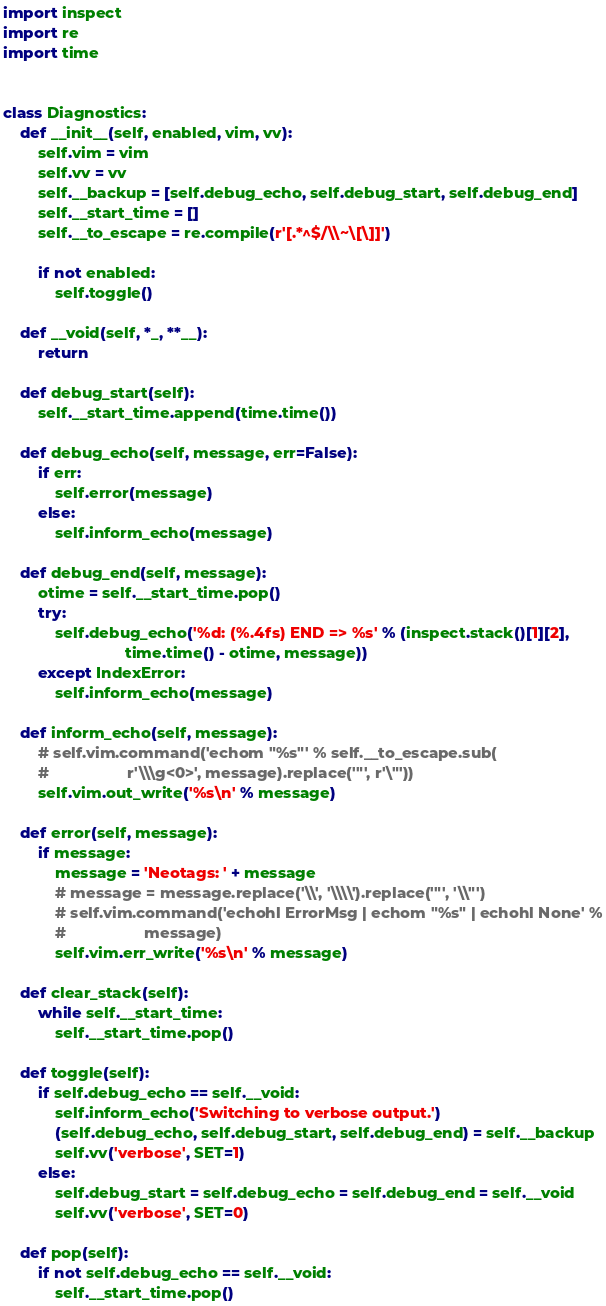Convert code to text. <code><loc_0><loc_0><loc_500><loc_500><_Python_>import inspect
import re
import time


class Diagnostics:
    def __init__(self, enabled, vim, vv):
        self.vim = vim
        self.vv = vv
        self.__backup = [self.debug_echo, self.debug_start, self.debug_end]
        self.__start_time = []
        self.__to_escape = re.compile(r'[.*^$/\\~\[\]]')

        if not enabled:
            self.toggle()

    def __void(self, *_, **__):
        return

    def debug_start(self):
        self.__start_time.append(time.time())

    def debug_echo(self, message, err=False):
        if err:
            self.error(message)
        else:
            self.inform_echo(message)

    def debug_end(self, message):
        otime = self.__start_time.pop()
        try:
            self.debug_echo('%d: (%.4fs) END => %s' % (inspect.stack()[1][2],
                            time.time() - otime, message))
        except IndexError:
            self.inform_echo(message)

    def inform_echo(self, message):
        # self.vim.command('echom "%s"' % self.__to_escape.sub(
        #                  r'\\\g<0>', message).replace('"', r'\"'))
        self.vim.out_write('%s\n' % message)

    def error(self, message):
        if message:
            message = 'Neotags: ' + message
            # message = message.replace('\\', '\\\\').replace('"', '\\"')
            # self.vim.command('echohl ErrorMsg | echom "%s" | echohl None' %
            #                  message)
            self.vim.err_write('%s\n' % message)

    def clear_stack(self):
        while self.__start_time:
            self.__start_time.pop()

    def toggle(self):
        if self.debug_echo == self.__void:
            self.inform_echo('Switching to verbose output.')
            (self.debug_echo, self.debug_start, self.debug_end) = self.__backup
            self.vv('verbose', SET=1)
        else:
            self.debug_start = self.debug_echo = self.debug_end = self.__void
            self.vv('verbose', SET=0)

    def pop(self):
        if not self.debug_echo == self.__void:
            self.__start_time.pop()
</code> 